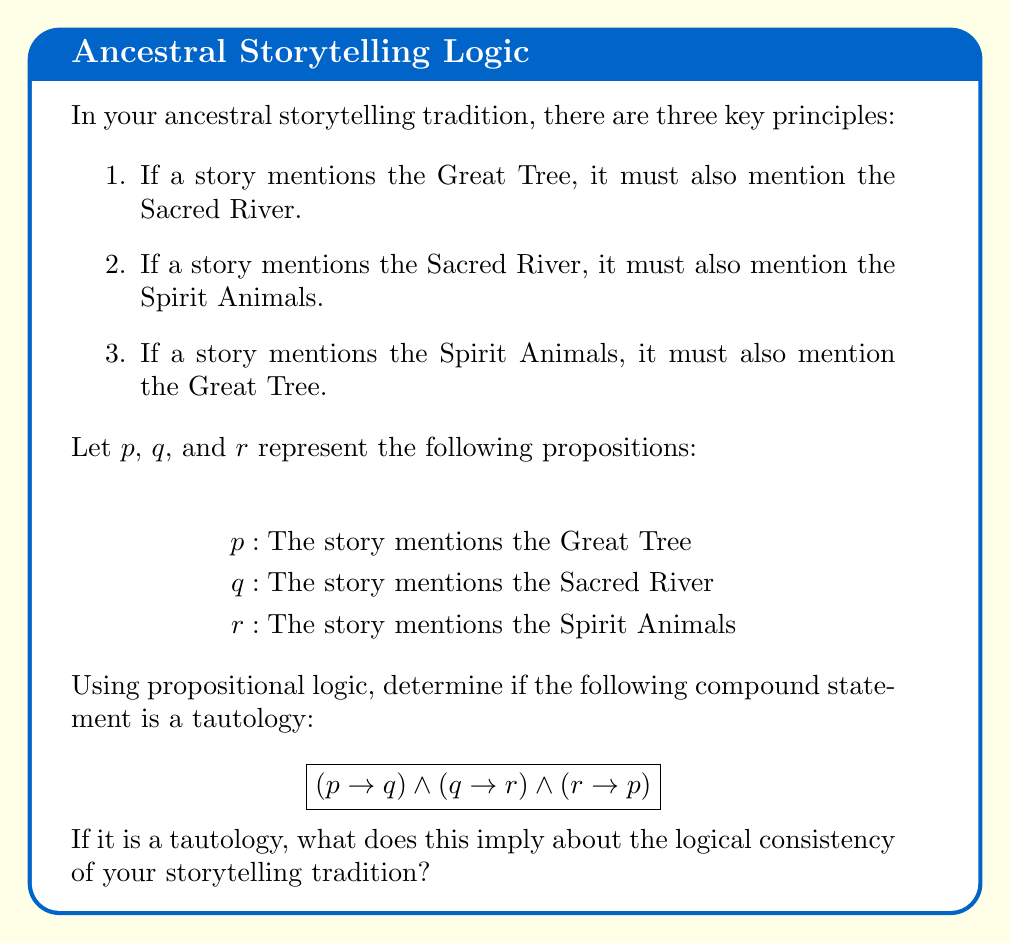Provide a solution to this math problem. To determine if the given compound statement is a tautology, we need to evaluate its truth value for all possible combinations of truth values for $p$, $q$, and $r$. We can do this using a truth table.

1. First, let's construct the truth table:

   | $p$ | $q$ | $r$ | $p \rightarrow q$ | $q \rightarrow r$ | $r \rightarrow p$ | $(p \rightarrow q) \land (q \rightarrow r) \land (r \rightarrow p)$ |
   |-----|-----|-----|-------------------|-------------------|-------------------|-------------------------------------------------------------------|
   | T   | T   | T   | T                 | T                 | T                 | T                                                                 |
   | T   | T   | F   | T                 | F                 | T                 | F                                                                 |
   | T   | F   | T   | F                 | T                 | T                 | F                                                                 |
   | T   | F   | F   | F                 | T                 | T                 | F                                                                 |
   | F   | T   | T   | T                 | T                 | F                 | F                                                                 |
   | F   | T   | F   | T                 | F                 | T                 | F                                                                 |
   | F   | F   | T   | T                 | T                 | F                 | F                                                                 |
   | F   | F   | F   | T                 | T                 | T                 | T                                                                 |

2. Analyzing the truth table:
   - We can see that the compound statement is true only when all three propositions ($p$, $q$, and $r$) are true, or when all three are false.
   - In all other cases, the compound statement is false.

3. For a statement to be a tautology, it must be true for all possible combinations of truth values of its component propositions.

4. Since our compound statement is not true for all combinations, it is not a tautology.

5. Implications for the storytelling tradition:
   - The logical structure of the tradition allows for two consistent scenarios:
     a) All three elements (Great Tree, Sacred River, and Spirit Animals) are present in a story.
     b) None of the three elements are present in a story.
   - Any other combination would violate at least one of the principles, making the tradition logically consistent but restrictive in its story elements.
Answer: Not a tautology; implies storytelling tradition is logically consistent but restrictive. 